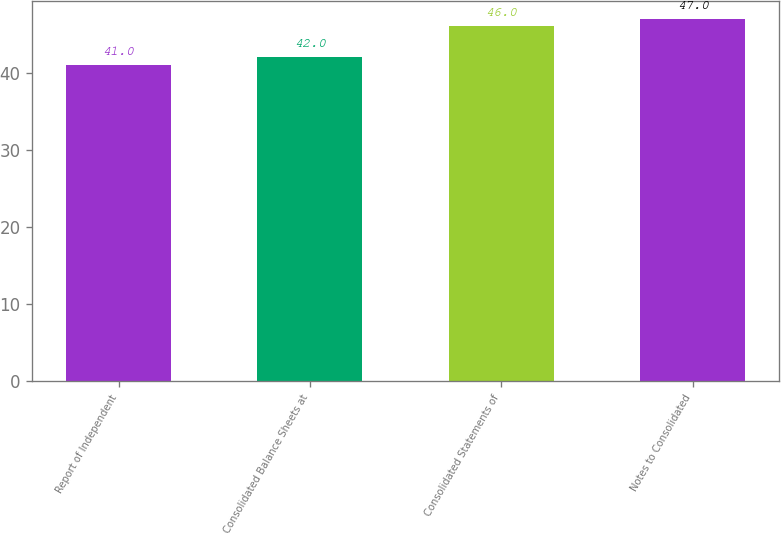Convert chart to OTSL. <chart><loc_0><loc_0><loc_500><loc_500><bar_chart><fcel>Report of Independent<fcel>Consolidated Balance Sheets at<fcel>Consolidated Statements of<fcel>Notes to Consolidated<nl><fcel>41<fcel>42<fcel>46<fcel>47<nl></chart> 